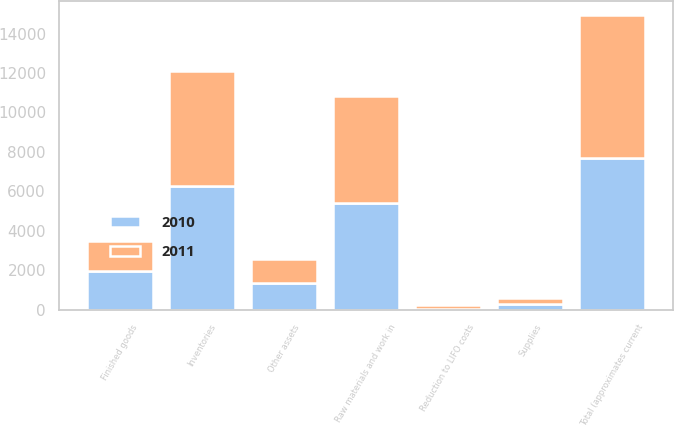Convert chart to OTSL. <chart><loc_0><loc_0><loc_500><loc_500><stacked_bar_chart><ecel><fcel>Finished goods<fcel>Raw materials and work in<fcel>Supplies<fcel>Total (approximates current<fcel>Reduction to LIFO costs<fcel>Inventories<fcel>Other assets<nl><fcel>2010<fcel>1983<fcel>5396<fcel>297<fcel>7676<fcel>43<fcel>6254<fcel>1379<nl><fcel>2011<fcel>1484<fcel>5449<fcel>315<fcel>7248<fcel>186<fcel>5868<fcel>1194<nl></chart> 